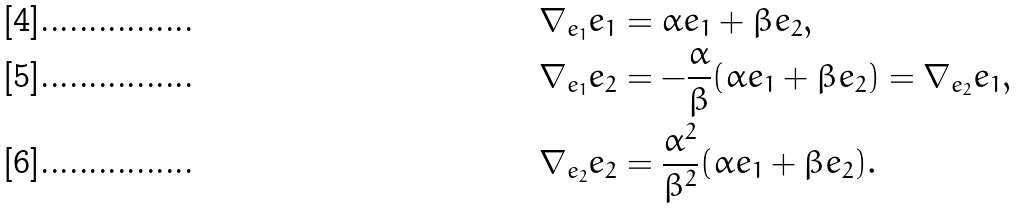Convert formula to latex. <formula><loc_0><loc_0><loc_500><loc_500>\nabla _ { e _ { 1 } } e _ { 1 } & = \alpha e _ { 1 } + \beta e _ { 2 } , \\ \nabla _ { e _ { 1 } } e _ { 2 } & = - \frac { \alpha } { \beta } ( \alpha e _ { 1 } + \beta e _ { 2 } ) = \nabla _ { e _ { 2 } } e _ { 1 } , \\ \nabla _ { e _ { 2 } } e _ { 2 } & = \frac { \alpha ^ { 2 } } { \beta ^ { 2 } } ( \alpha e _ { 1 } + \beta e _ { 2 } ) .</formula> 